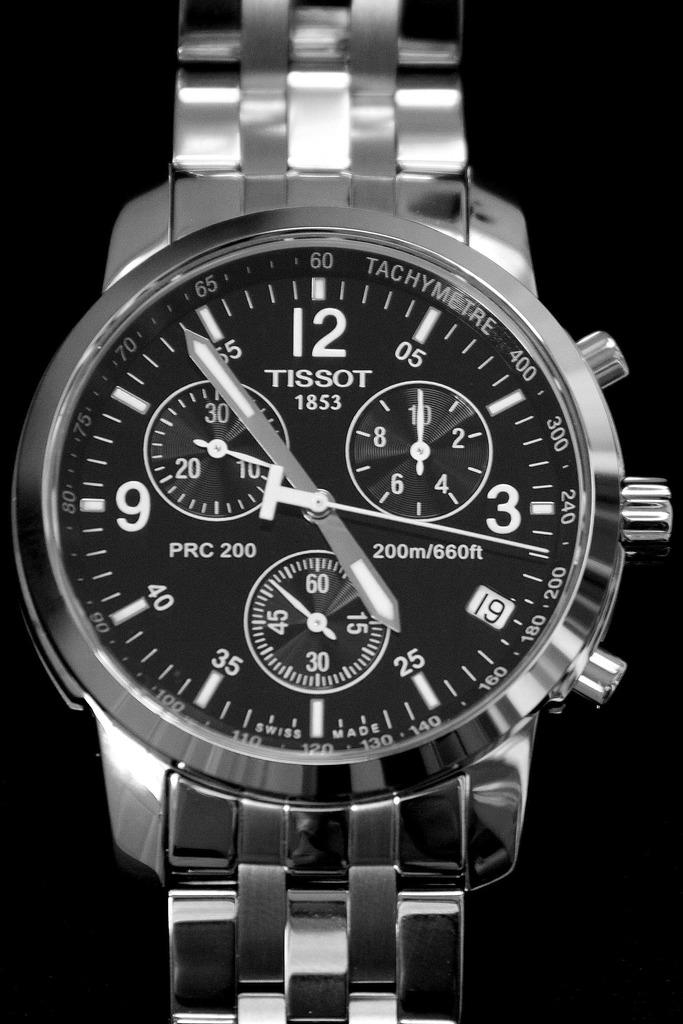<image>
Share a concise interpretation of the image provided. Tissot watch that includs a timer and the time that is silver 